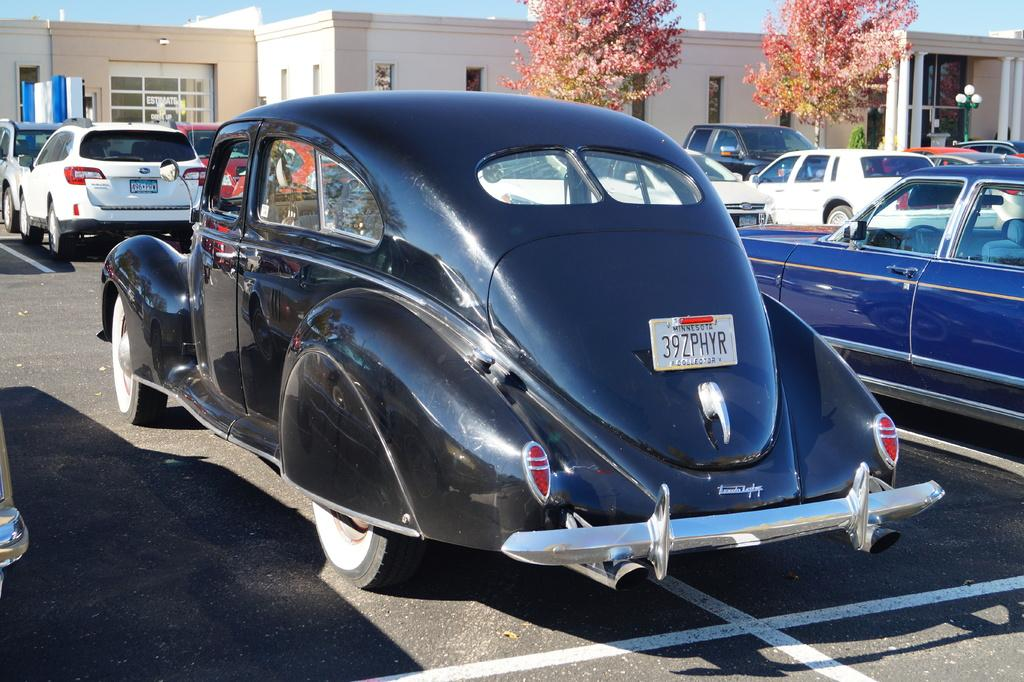What is the main subject of the image? The main subject of the image is a group of vehicles. Where are the vehicles located in the image? The vehicles are parked in a parking lot. What can be seen in the background of the image? There is a building, a group of trees, a pole, and the sky visible in the background of the image. What type of wool is being used to make the pig's scale in the image? There is no wool, pig, or scale present in the image. 